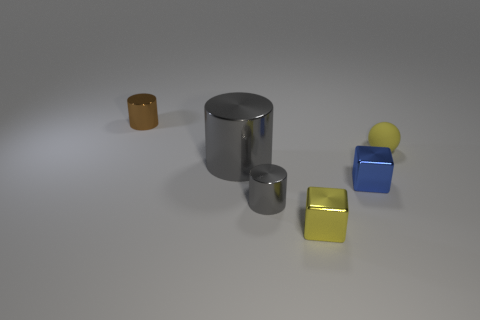There is a metal thing behind the tiny matte ball; does it have the same shape as the large gray metal object?
Your answer should be compact. Yes. Are there more yellow objects behind the small gray shiny cylinder than gray cubes?
Give a very brief answer. Yes. Are there any other things that have the same material as the small yellow sphere?
Ensure brevity in your answer.  No. There is a small metallic object that is the same color as the tiny matte thing; what is its shape?
Offer a terse response. Cube. How many cylinders are large things or tiny brown metal things?
Give a very brief answer. 2. What color is the tiny metal cylinder that is in front of the tiny thing to the left of the big thing?
Ensure brevity in your answer.  Gray. There is a tiny rubber thing; does it have the same color as the tiny metal thing that is on the left side of the big metal object?
Ensure brevity in your answer.  No. What is the size of the gray object that is made of the same material as the tiny gray cylinder?
Your response must be concise. Large. Is the ball the same color as the big metallic cylinder?
Ensure brevity in your answer.  No. Are there any small blue shiny blocks that are behind the small metal cylinder that is in front of the tiny yellow thing that is behind the tiny gray shiny object?
Make the answer very short. Yes. 